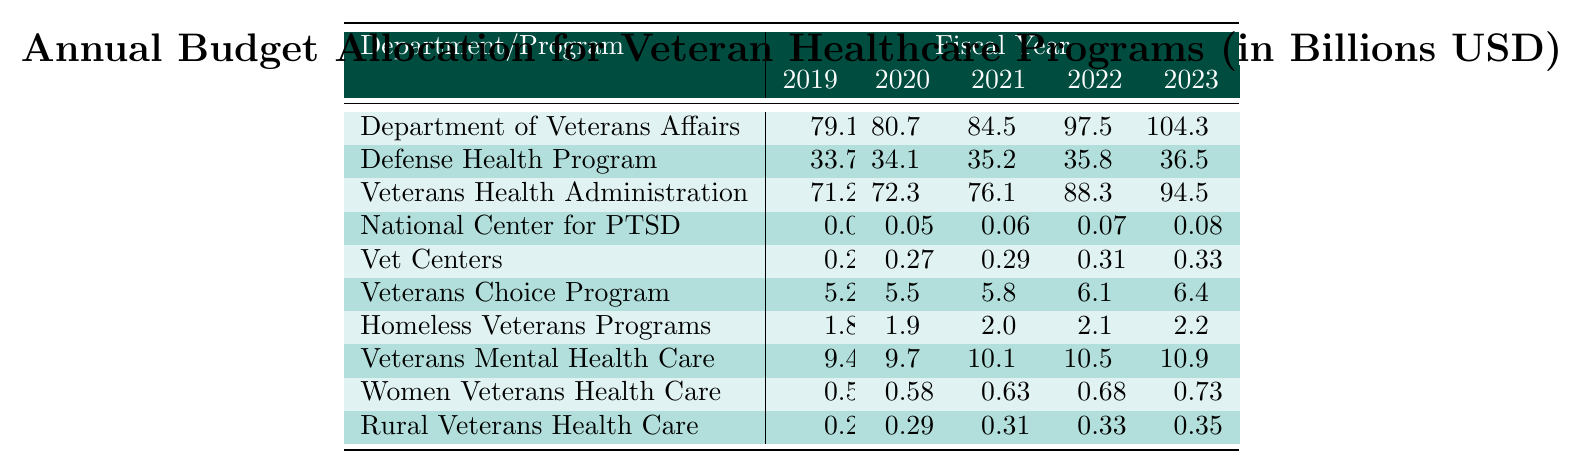What was the budget allocation for the Department of Veterans Affairs in 2022? According to the table, the budget allocation for the Department of Veterans Affairs in 2022 is listed directly as 97.5 billion USD.
Answer: 97.5 billion USD What is the trend in budget allocation for Women's Veterans Health Care from 2019 to 2023? By looking at the values from 2019 (0.53), 2020 (0.58), 2021 (0.63), 2022 (0.68), and 2023 (0.73), we see an increase each year. Therefore, the trend indicates that the budget allocation is increasing.
Answer: Increasing How much more was allocated to the Veterans Health Administration in 2023 compared to 2019? The allocation for Veterans Health Administration in 2023 is 94.5 billion USD and in 2019 it was 71.2 billion USD. The difference is 94.5 - 71.2 = 23.3 billion USD more.
Answer: 23.3 billion USD What is the total budget allocation for all veteran healthcare programs in the fiscal year 2021? By summing up the allocations for 2021: (84.5 + 35.2 + 76.1 + 0.06 + 0.29 + 5.8 + 2.0 + 10.1 + 0.63 + 0.31), the total equals 214.91 billion USD.
Answer: 214.91 billion USD In which year did the Defense Health Program have the highest allocation? Looking at the values for the Defense Health Program, the allocations are 33.7 (2019), 34.1 (2020), 35.2 (2021), 35.8 (2022), and 36.5 (2023). The greatest value is 36.5 in 2023, indicating that is the highest allocation.
Answer: 2023 Is the budget for the National Center for PTSD greater than 0.1 billion USD in any year? The values for the National Center for PTSD are 0.04, 0.05, 0.06, 0.07, and 0.08 billion USD from 2019 to 2023, none of which exceed 0.1 billion USD. Thus, it is false that the budget is greater than 0.1 billion USD in any year.
Answer: No What is the average budget allocation for the Rural Veterans Health Care program over the years listed? The values for Rural Veterans Health Care are 0.27, 0.29, 0.31, 0.33, and 0.35. Summing these gives 0.27 + 0.29 + 0.31 + 0.33 + 0.35 = 1.55. Dividing by the number of years (5), the average allocation is 1.55 / 5 = 0.31 billion USD.
Answer: 0.31 billion USD Which program saw the smallest budget in 2019? A comparison of all programs in 2019 shows that the National Center for PTSD (0.04 billion USD) has the smallest budget allocation.
Answer: National Center for PTSD By how much did the overall budget for veteran healthcare programs increase from 2019 to 2023? Summing the total budget allocation for 2019 is 79.1 + 33.7 + 71.2 + 0.04 + 0.25 + 5.2 + 1.8 + 9.4 + 0.53 + 0.27 = 201.7 billion USD. The total for 2023 is 104.3 + 36.5 + 94.5 + 0.08 + 0.33 + 6.4 + 2.2 + 10.9 + 0.73 + 0.35 = 255.6 billion USD. The increase is 255.6 - 201.7 = 53.9 billion USD.
Answer: 53.9 billion USD 